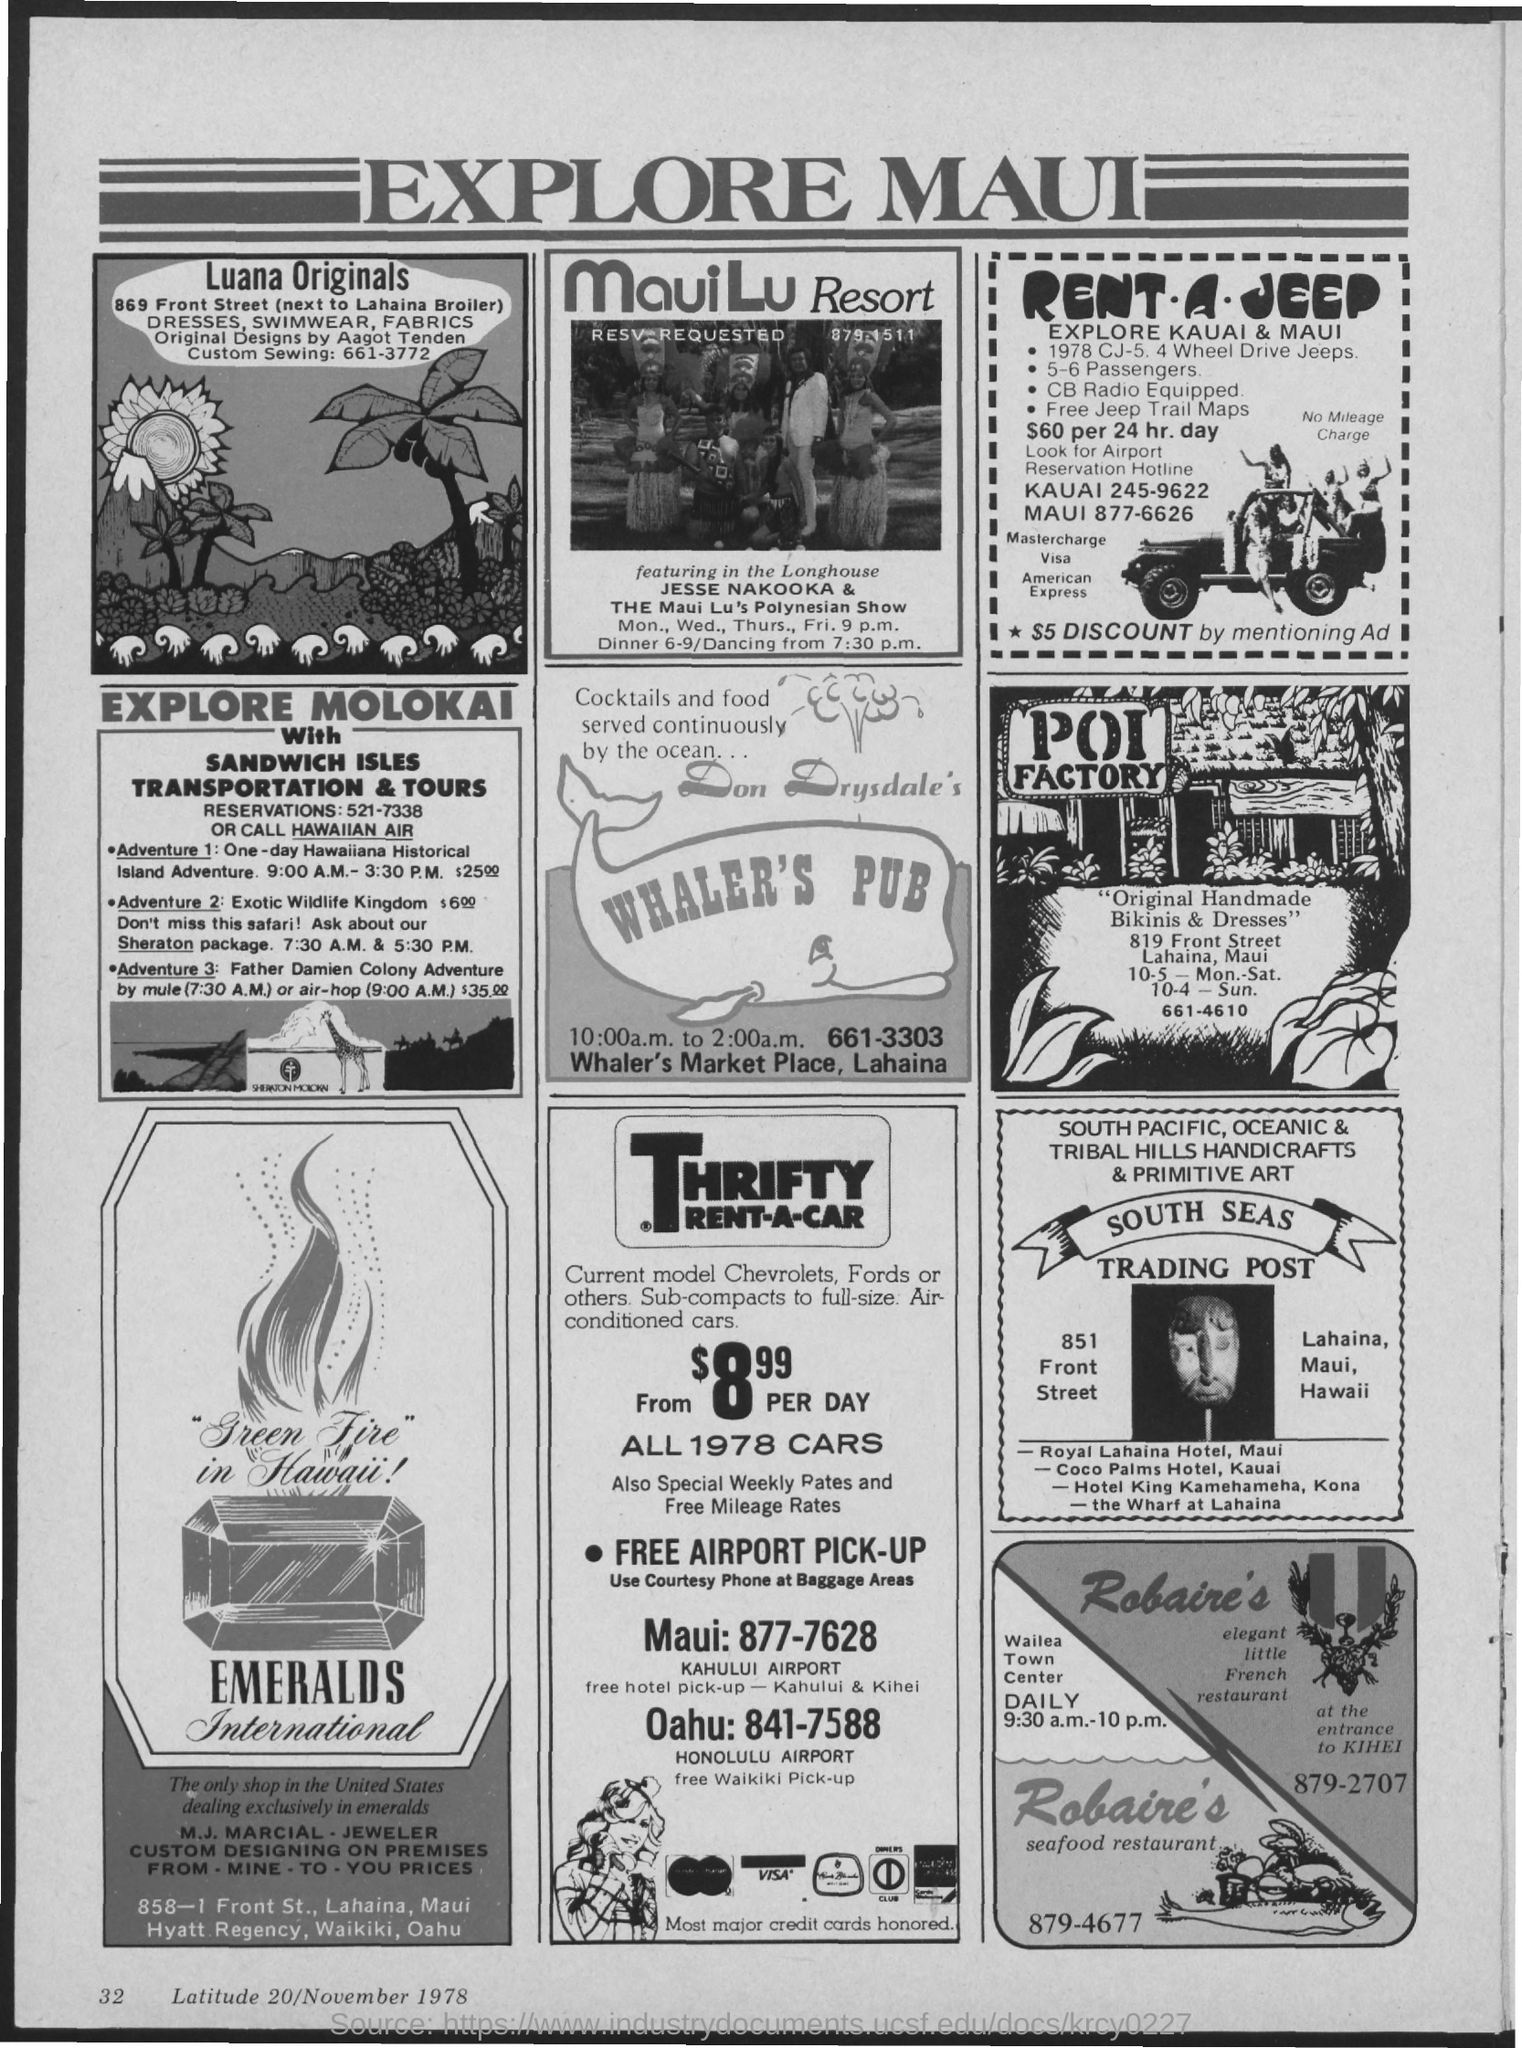Identify some key points in this picture. The heading of the advertisement is 'Explore Maui.' The address of Whaler's Pub is located at Whaler's Market Place in Lahaina. 